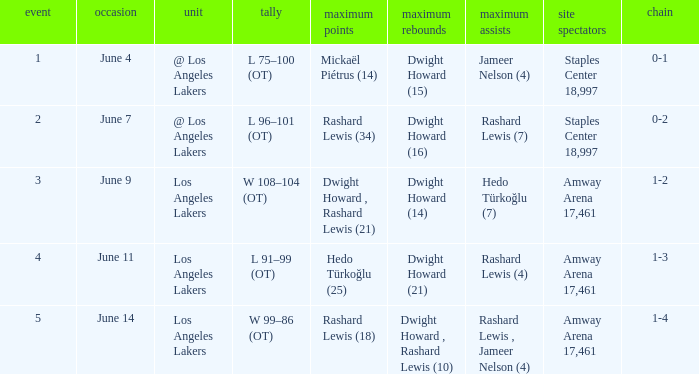What is Team, when High Assists is "Rashard Lewis (4)"? Los Angeles Lakers. Parse the table in full. {'header': ['event', 'occasion', 'unit', 'tally', 'maximum points', 'maximum rebounds', 'maximum assists', 'site spectators', 'chain'], 'rows': [['1', 'June 4', '@ Los Angeles Lakers', 'L 75–100 (OT)', 'Mickaël Piétrus (14)', 'Dwight Howard (15)', 'Jameer Nelson (4)', 'Staples Center 18,997', '0-1'], ['2', 'June 7', '@ Los Angeles Lakers', 'L 96–101 (OT)', 'Rashard Lewis (34)', 'Dwight Howard (16)', 'Rashard Lewis (7)', 'Staples Center 18,997', '0-2'], ['3', 'June 9', 'Los Angeles Lakers', 'W 108–104 (OT)', 'Dwight Howard , Rashard Lewis (21)', 'Dwight Howard (14)', 'Hedo Türkoğlu (7)', 'Amway Arena 17,461', '1-2'], ['4', 'June 11', 'Los Angeles Lakers', 'L 91–99 (OT)', 'Hedo Türkoğlu (25)', 'Dwight Howard (21)', 'Rashard Lewis (4)', 'Amway Arena 17,461', '1-3'], ['5', 'June 14', 'Los Angeles Lakers', 'W 99–86 (OT)', 'Rashard Lewis (18)', 'Dwight Howard , Rashard Lewis (10)', 'Rashard Lewis , Jameer Nelson (4)', 'Amway Arena 17,461', '1-4']]} 